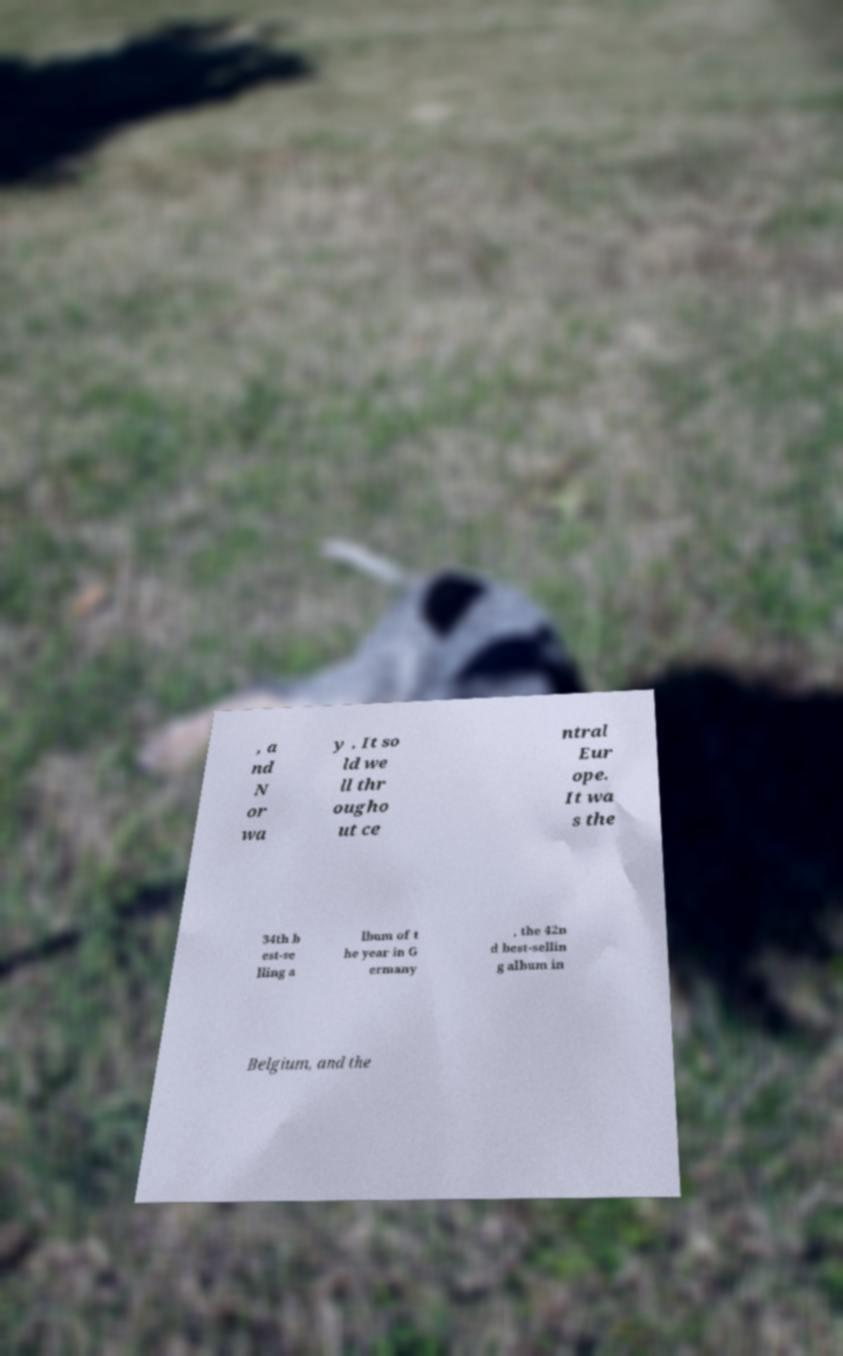For documentation purposes, I need the text within this image transcribed. Could you provide that? , a nd N or wa y . It so ld we ll thr ougho ut ce ntral Eur ope. It wa s the 34th b est-se lling a lbum of t he year in G ermany , the 42n d best-sellin g album in Belgium, and the 